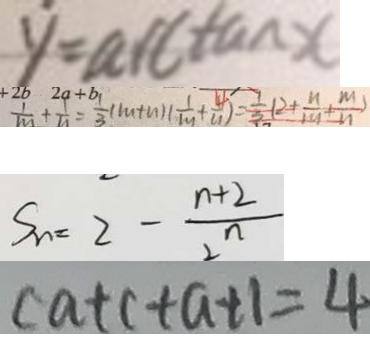<formula> <loc_0><loc_0><loc_500><loc_500>y = \arctan x 
 \frac { 1 } { m } + \frac { 1 } { n } = \frac { 1 } { 3 } ( m + n ) ( \frac { 1 } { m } + \frac { 4 } { n } ) = \frac { 1 } { 3 } ( 2 + \frac { n } { m } + \frac { m } { n } ) 
 S _ { n } = 2 - \frac { n + 2 } { 2 ^ { n } } 
 c a + c + a + 1 = 4</formula> 